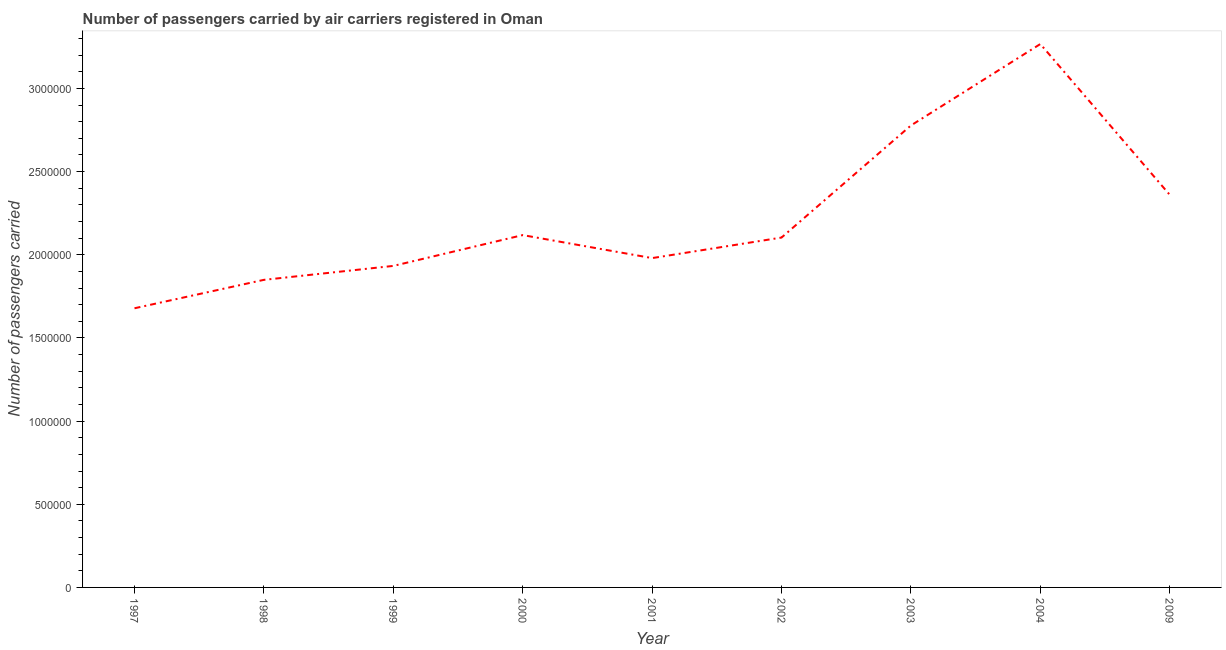What is the number of passengers carried in 1998?
Provide a succinct answer. 1.85e+06. Across all years, what is the maximum number of passengers carried?
Your answer should be very brief. 3.27e+06. Across all years, what is the minimum number of passengers carried?
Offer a very short reply. 1.68e+06. In which year was the number of passengers carried maximum?
Ensure brevity in your answer.  2004. In which year was the number of passengers carried minimum?
Your answer should be compact. 1997. What is the sum of the number of passengers carried?
Offer a terse response. 2.01e+07. What is the difference between the number of passengers carried in 1997 and 1998?
Make the answer very short. -1.71e+05. What is the average number of passengers carried per year?
Provide a succinct answer. 2.23e+06. What is the median number of passengers carried?
Offer a terse response. 2.10e+06. In how many years, is the number of passengers carried greater than 2600000 ?
Offer a terse response. 2. What is the ratio of the number of passengers carried in 2000 to that in 2001?
Ensure brevity in your answer.  1.07. Is the difference between the number of passengers carried in 2001 and 2009 greater than the difference between any two years?
Provide a short and direct response. No. What is the difference between the highest and the second highest number of passengers carried?
Keep it short and to the point. 4.90e+05. Is the sum of the number of passengers carried in 1997 and 1999 greater than the maximum number of passengers carried across all years?
Provide a succinct answer. Yes. What is the difference between the highest and the lowest number of passengers carried?
Offer a very short reply. 1.59e+06. In how many years, is the number of passengers carried greater than the average number of passengers carried taken over all years?
Your answer should be very brief. 3. How many lines are there?
Offer a very short reply. 1. How many years are there in the graph?
Your response must be concise. 9. What is the difference between two consecutive major ticks on the Y-axis?
Offer a very short reply. 5.00e+05. Are the values on the major ticks of Y-axis written in scientific E-notation?
Ensure brevity in your answer.  No. What is the title of the graph?
Your answer should be very brief. Number of passengers carried by air carriers registered in Oman. What is the label or title of the X-axis?
Keep it short and to the point. Year. What is the label or title of the Y-axis?
Provide a short and direct response. Number of passengers carried. What is the Number of passengers carried in 1997?
Provide a short and direct response. 1.68e+06. What is the Number of passengers carried in 1998?
Offer a terse response. 1.85e+06. What is the Number of passengers carried in 1999?
Your answer should be compact. 1.93e+06. What is the Number of passengers carried of 2000?
Keep it short and to the point. 2.12e+06. What is the Number of passengers carried in 2001?
Ensure brevity in your answer.  1.98e+06. What is the Number of passengers carried of 2002?
Provide a short and direct response. 2.10e+06. What is the Number of passengers carried of 2003?
Offer a terse response. 2.78e+06. What is the Number of passengers carried in 2004?
Keep it short and to the point. 3.27e+06. What is the Number of passengers carried in 2009?
Your answer should be compact. 2.36e+06. What is the difference between the Number of passengers carried in 1997 and 1998?
Make the answer very short. -1.71e+05. What is the difference between the Number of passengers carried in 1997 and 1999?
Your answer should be compact. -2.55e+05. What is the difference between the Number of passengers carried in 1997 and 2000?
Your response must be concise. -4.40e+05. What is the difference between the Number of passengers carried in 1997 and 2001?
Provide a succinct answer. -3.02e+05. What is the difference between the Number of passengers carried in 1997 and 2002?
Keep it short and to the point. -4.25e+05. What is the difference between the Number of passengers carried in 1997 and 2003?
Make the answer very short. -1.10e+06. What is the difference between the Number of passengers carried in 1997 and 2004?
Your response must be concise. -1.59e+06. What is the difference between the Number of passengers carried in 1997 and 2009?
Give a very brief answer. -6.82e+05. What is the difference between the Number of passengers carried in 1998 and 1999?
Offer a terse response. -8.38e+04. What is the difference between the Number of passengers carried in 1998 and 2000?
Offer a terse response. -2.69e+05. What is the difference between the Number of passengers carried in 1998 and 2001?
Keep it short and to the point. -1.31e+05. What is the difference between the Number of passengers carried in 1998 and 2002?
Provide a short and direct response. -2.54e+05. What is the difference between the Number of passengers carried in 1998 and 2003?
Your answer should be compact. -9.28e+05. What is the difference between the Number of passengers carried in 1998 and 2004?
Your response must be concise. -1.42e+06. What is the difference between the Number of passengers carried in 1998 and 2009?
Keep it short and to the point. -5.11e+05. What is the difference between the Number of passengers carried in 1999 and 2000?
Your answer should be compact. -1.85e+05. What is the difference between the Number of passengers carried in 1999 and 2001?
Make the answer very short. -4.70e+04. What is the difference between the Number of passengers carried in 1999 and 2002?
Offer a terse response. -1.70e+05. What is the difference between the Number of passengers carried in 1999 and 2003?
Your answer should be very brief. -8.44e+05. What is the difference between the Number of passengers carried in 1999 and 2004?
Make the answer very short. -1.33e+06. What is the difference between the Number of passengers carried in 1999 and 2009?
Offer a terse response. -4.28e+05. What is the difference between the Number of passengers carried in 2000 and 2001?
Keep it short and to the point. 1.38e+05. What is the difference between the Number of passengers carried in 2000 and 2002?
Your answer should be very brief. 1.48e+04. What is the difference between the Number of passengers carried in 2000 and 2003?
Offer a terse response. -6.59e+05. What is the difference between the Number of passengers carried in 2000 and 2004?
Your response must be concise. -1.15e+06. What is the difference between the Number of passengers carried in 2000 and 2009?
Give a very brief answer. -2.42e+05. What is the difference between the Number of passengers carried in 2001 and 2002?
Your answer should be very brief. -1.23e+05. What is the difference between the Number of passengers carried in 2001 and 2003?
Provide a succinct answer. -7.97e+05. What is the difference between the Number of passengers carried in 2001 and 2004?
Offer a very short reply. -1.29e+06. What is the difference between the Number of passengers carried in 2001 and 2009?
Ensure brevity in your answer.  -3.81e+05. What is the difference between the Number of passengers carried in 2002 and 2003?
Your response must be concise. -6.74e+05. What is the difference between the Number of passengers carried in 2002 and 2004?
Your answer should be very brief. -1.16e+06. What is the difference between the Number of passengers carried in 2002 and 2009?
Your answer should be very brief. -2.57e+05. What is the difference between the Number of passengers carried in 2003 and 2004?
Offer a very short reply. -4.90e+05. What is the difference between the Number of passengers carried in 2003 and 2009?
Offer a very short reply. 4.17e+05. What is the difference between the Number of passengers carried in 2004 and 2009?
Offer a very short reply. 9.06e+05. What is the ratio of the Number of passengers carried in 1997 to that in 1998?
Your answer should be very brief. 0.91. What is the ratio of the Number of passengers carried in 1997 to that in 1999?
Ensure brevity in your answer.  0.87. What is the ratio of the Number of passengers carried in 1997 to that in 2000?
Give a very brief answer. 0.79. What is the ratio of the Number of passengers carried in 1997 to that in 2001?
Provide a short and direct response. 0.85. What is the ratio of the Number of passengers carried in 1997 to that in 2002?
Make the answer very short. 0.8. What is the ratio of the Number of passengers carried in 1997 to that in 2003?
Make the answer very short. 0.6. What is the ratio of the Number of passengers carried in 1997 to that in 2004?
Provide a short and direct response. 0.51. What is the ratio of the Number of passengers carried in 1997 to that in 2009?
Ensure brevity in your answer.  0.71. What is the ratio of the Number of passengers carried in 1998 to that in 2000?
Offer a very short reply. 0.87. What is the ratio of the Number of passengers carried in 1998 to that in 2001?
Provide a succinct answer. 0.93. What is the ratio of the Number of passengers carried in 1998 to that in 2002?
Keep it short and to the point. 0.88. What is the ratio of the Number of passengers carried in 1998 to that in 2003?
Offer a terse response. 0.67. What is the ratio of the Number of passengers carried in 1998 to that in 2004?
Offer a very short reply. 0.57. What is the ratio of the Number of passengers carried in 1998 to that in 2009?
Make the answer very short. 0.78. What is the ratio of the Number of passengers carried in 1999 to that in 2000?
Your answer should be very brief. 0.91. What is the ratio of the Number of passengers carried in 1999 to that in 2001?
Your answer should be very brief. 0.98. What is the ratio of the Number of passengers carried in 1999 to that in 2002?
Offer a very short reply. 0.92. What is the ratio of the Number of passengers carried in 1999 to that in 2003?
Offer a terse response. 0.7. What is the ratio of the Number of passengers carried in 1999 to that in 2004?
Give a very brief answer. 0.59. What is the ratio of the Number of passengers carried in 1999 to that in 2009?
Your response must be concise. 0.82. What is the ratio of the Number of passengers carried in 2000 to that in 2001?
Your answer should be compact. 1.07. What is the ratio of the Number of passengers carried in 2000 to that in 2002?
Provide a succinct answer. 1.01. What is the ratio of the Number of passengers carried in 2000 to that in 2003?
Make the answer very short. 0.76. What is the ratio of the Number of passengers carried in 2000 to that in 2004?
Your answer should be very brief. 0.65. What is the ratio of the Number of passengers carried in 2000 to that in 2009?
Provide a short and direct response. 0.9. What is the ratio of the Number of passengers carried in 2001 to that in 2002?
Provide a succinct answer. 0.94. What is the ratio of the Number of passengers carried in 2001 to that in 2003?
Ensure brevity in your answer.  0.71. What is the ratio of the Number of passengers carried in 2001 to that in 2004?
Your response must be concise. 0.61. What is the ratio of the Number of passengers carried in 2001 to that in 2009?
Give a very brief answer. 0.84. What is the ratio of the Number of passengers carried in 2002 to that in 2003?
Keep it short and to the point. 0.76. What is the ratio of the Number of passengers carried in 2002 to that in 2004?
Give a very brief answer. 0.64. What is the ratio of the Number of passengers carried in 2002 to that in 2009?
Provide a succinct answer. 0.89. What is the ratio of the Number of passengers carried in 2003 to that in 2004?
Keep it short and to the point. 0.85. What is the ratio of the Number of passengers carried in 2003 to that in 2009?
Make the answer very short. 1.18. What is the ratio of the Number of passengers carried in 2004 to that in 2009?
Make the answer very short. 1.38. 